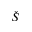Convert formula to latex. <formula><loc_0><loc_0><loc_500><loc_500>\check { S }</formula> 